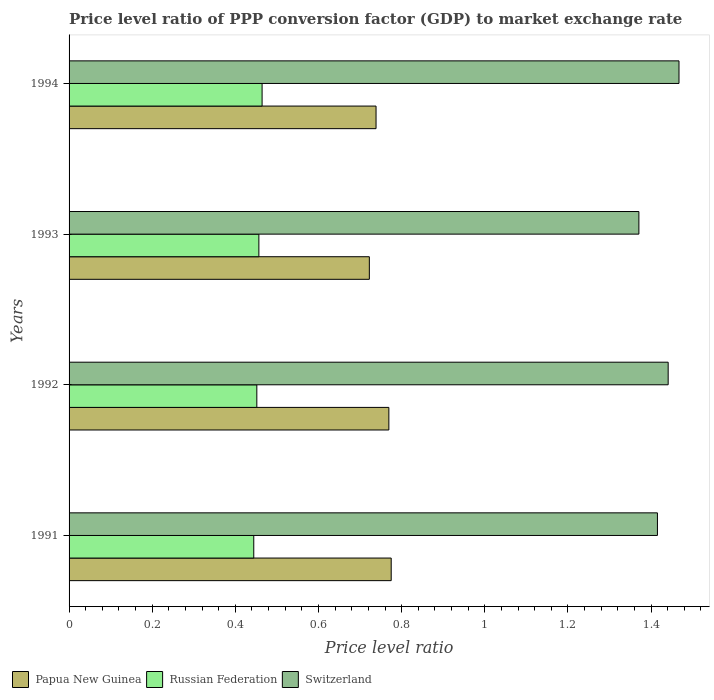How many different coloured bars are there?
Offer a terse response. 3. How many groups of bars are there?
Give a very brief answer. 4. How many bars are there on the 1st tick from the top?
Make the answer very short. 3. What is the label of the 1st group of bars from the top?
Make the answer very short. 1994. In how many cases, is the number of bars for a given year not equal to the number of legend labels?
Offer a very short reply. 0. What is the price level ratio in Russian Federation in 1993?
Ensure brevity in your answer.  0.46. Across all years, what is the maximum price level ratio in Papua New Guinea?
Give a very brief answer. 0.77. Across all years, what is the minimum price level ratio in Papua New Guinea?
Your response must be concise. 0.72. In which year was the price level ratio in Switzerland maximum?
Your response must be concise. 1994. What is the total price level ratio in Switzerland in the graph?
Give a very brief answer. 5.69. What is the difference between the price level ratio in Papua New Guinea in 1992 and that in 1993?
Make the answer very short. 0.05. What is the difference between the price level ratio in Papua New Guinea in 1992 and the price level ratio in Switzerland in 1994?
Your answer should be compact. -0.7. What is the average price level ratio in Papua New Guinea per year?
Make the answer very short. 0.75. In the year 1992, what is the difference between the price level ratio in Switzerland and price level ratio in Papua New Guinea?
Give a very brief answer. 0.67. In how many years, is the price level ratio in Papua New Guinea greater than 0.7200000000000001 ?
Provide a succinct answer. 4. What is the ratio of the price level ratio in Papua New Guinea in 1992 to that in 1993?
Provide a succinct answer. 1.06. Is the price level ratio in Papua New Guinea in 1991 less than that in 1993?
Provide a short and direct response. No. What is the difference between the highest and the second highest price level ratio in Papua New Guinea?
Provide a succinct answer. 0.01. What is the difference between the highest and the lowest price level ratio in Switzerland?
Provide a short and direct response. 0.1. In how many years, is the price level ratio in Russian Federation greater than the average price level ratio in Russian Federation taken over all years?
Offer a terse response. 2. Is the sum of the price level ratio in Papua New Guinea in 1992 and 1993 greater than the maximum price level ratio in Russian Federation across all years?
Make the answer very short. Yes. What does the 3rd bar from the top in 1993 represents?
Give a very brief answer. Papua New Guinea. What does the 2nd bar from the bottom in 1992 represents?
Keep it short and to the point. Russian Federation. How many bars are there?
Your answer should be very brief. 12. What is the difference between two consecutive major ticks on the X-axis?
Offer a terse response. 0.2. Does the graph contain any zero values?
Offer a very short reply. No. Where does the legend appear in the graph?
Offer a very short reply. Bottom left. What is the title of the graph?
Your answer should be very brief. Price level ratio of PPP conversion factor (GDP) to market exchange rate. What is the label or title of the X-axis?
Provide a short and direct response. Price level ratio. What is the label or title of the Y-axis?
Keep it short and to the point. Years. What is the Price level ratio in Papua New Guinea in 1991?
Provide a succinct answer. 0.77. What is the Price level ratio in Russian Federation in 1991?
Your answer should be very brief. 0.44. What is the Price level ratio of Switzerland in 1991?
Offer a very short reply. 1.42. What is the Price level ratio in Papua New Guinea in 1992?
Provide a succinct answer. 0.77. What is the Price level ratio of Russian Federation in 1992?
Provide a short and direct response. 0.45. What is the Price level ratio of Switzerland in 1992?
Offer a terse response. 1.44. What is the Price level ratio of Papua New Guinea in 1993?
Offer a terse response. 0.72. What is the Price level ratio in Russian Federation in 1993?
Make the answer very short. 0.46. What is the Price level ratio in Switzerland in 1993?
Your answer should be very brief. 1.37. What is the Price level ratio of Papua New Guinea in 1994?
Your response must be concise. 0.74. What is the Price level ratio in Russian Federation in 1994?
Provide a succinct answer. 0.46. What is the Price level ratio in Switzerland in 1994?
Make the answer very short. 1.47. Across all years, what is the maximum Price level ratio in Papua New Guinea?
Your response must be concise. 0.77. Across all years, what is the maximum Price level ratio of Russian Federation?
Give a very brief answer. 0.46. Across all years, what is the maximum Price level ratio in Switzerland?
Offer a very short reply. 1.47. Across all years, what is the minimum Price level ratio in Papua New Guinea?
Ensure brevity in your answer.  0.72. Across all years, what is the minimum Price level ratio in Russian Federation?
Offer a very short reply. 0.44. Across all years, what is the minimum Price level ratio in Switzerland?
Make the answer very short. 1.37. What is the total Price level ratio in Papua New Guinea in the graph?
Ensure brevity in your answer.  3. What is the total Price level ratio of Russian Federation in the graph?
Provide a succinct answer. 1.82. What is the total Price level ratio of Switzerland in the graph?
Provide a short and direct response. 5.69. What is the difference between the Price level ratio of Papua New Guinea in 1991 and that in 1992?
Ensure brevity in your answer.  0.01. What is the difference between the Price level ratio in Russian Federation in 1991 and that in 1992?
Give a very brief answer. -0.01. What is the difference between the Price level ratio in Switzerland in 1991 and that in 1992?
Make the answer very short. -0.03. What is the difference between the Price level ratio in Papua New Guinea in 1991 and that in 1993?
Your response must be concise. 0.05. What is the difference between the Price level ratio of Russian Federation in 1991 and that in 1993?
Provide a short and direct response. -0.01. What is the difference between the Price level ratio of Switzerland in 1991 and that in 1993?
Ensure brevity in your answer.  0.04. What is the difference between the Price level ratio of Papua New Guinea in 1991 and that in 1994?
Make the answer very short. 0.04. What is the difference between the Price level ratio in Russian Federation in 1991 and that in 1994?
Offer a very short reply. -0.02. What is the difference between the Price level ratio of Switzerland in 1991 and that in 1994?
Your answer should be very brief. -0.05. What is the difference between the Price level ratio in Papua New Guinea in 1992 and that in 1993?
Ensure brevity in your answer.  0.05. What is the difference between the Price level ratio of Russian Federation in 1992 and that in 1993?
Your response must be concise. -0. What is the difference between the Price level ratio in Switzerland in 1992 and that in 1993?
Give a very brief answer. 0.07. What is the difference between the Price level ratio of Papua New Guinea in 1992 and that in 1994?
Offer a very short reply. 0.03. What is the difference between the Price level ratio of Russian Federation in 1992 and that in 1994?
Provide a short and direct response. -0.01. What is the difference between the Price level ratio of Switzerland in 1992 and that in 1994?
Your answer should be compact. -0.03. What is the difference between the Price level ratio in Papua New Guinea in 1993 and that in 1994?
Give a very brief answer. -0.02. What is the difference between the Price level ratio in Russian Federation in 1993 and that in 1994?
Keep it short and to the point. -0.01. What is the difference between the Price level ratio in Switzerland in 1993 and that in 1994?
Your answer should be very brief. -0.1. What is the difference between the Price level ratio of Papua New Guinea in 1991 and the Price level ratio of Russian Federation in 1992?
Ensure brevity in your answer.  0.32. What is the difference between the Price level ratio of Papua New Guinea in 1991 and the Price level ratio of Switzerland in 1992?
Your response must be concise. -0.67. What is the difference between the Price level ratio of Russian Federation in 1991 and the Price level ratio of Switzerland in 1992?
Give a very brief answer. -1. What is the difference between the Price level ratio in Papua New Guinea in 1991 and the Price level ratio in Russian Federation in 1993?
Ensure brevity in your answer.  0.32. What is the difference between the Price level ratio in Papua New Guinea in 1991 and the Price level ratio in Switzerland in 1993?
Make the answer very short. -0.6. What is the difference between the Price level ratio of Russian Federation in 1991 and the Price level ratio of Switzerland in 1993?
Provide a short and direct response. -0.93. What is the difference between the Price level ratio of Papua New Guinea in 1991 and the Price level ratio of Russian Federation in 1994?
Give a very brief answer. 0.31. What is the difference between the Price level ratio of Papua New Guinea in 1991 and the Price level ratio of Switzerland in 1994?
Keep it short and to the point. -0.69. What is the difference between the Price level ratio in Russian Federation in 1991 and the Price level ratio in Switzerland in 1994?
Give a very brief answer. -1.02. What is the difference between the Price level ratio of Papua New Guinea in 1992 and the Price level ratio of Russian Federation in 1993?
Your answer should be very brief. 0.31. What is the difference between the Price level ratio of Papua New Guinea in 1992 and the Price level ratio of Switzerland in 1993?
Provide a short and direct response. -0.6. What is the difference between the Price level ratio in Russian Federation in 1992 and the Price level ratio in Switzerland in 1993?
Provide a succinct answer. -0.92. What is the difference between the Price level ratio in Papua New Guinea in 1992 and the Price level ratio in Russian Federation in 1994?
Offer a terse response. 0.3. What is the difference between the Price level ratio of Papua New Guinea in 1992 and the Price level ratio of Switzerland in 1994?
Offer a terse response. -0.7. What is the difference between the Price level ratio in Russian Federation in 1992 and the Price level ratio in Switzerland in 1994?
Ensure brevity in your answer.  -1.02. What is the difference between the Price level ratio in Papua New Guinea in 1993 and the Price level ratio in Russian Federation in 1994?
Make the answer very short. 0.26. What is the difference between the Price level ratio in Papua New Guinea in 1993 and the Price level ratio in Switzerland in 1994?
Ensure brevity in your answer.  -0.74. What is the difference between the Price level ratio of Russian Federation in 1993 and the Price level ratio of Switzerland in 1994?
Your answer should be very brief. -1.01. What is the average Price level ratio in Papua New Guinea per year?
Your answer should be very brief. 0.75. What is the average Price level ratio in Russian Federation per year?
Your answer should be very brief. 0.45. What is the average Price level ratio in Switzerland per year?
Offer a terse response. 1.42. In the year 1991, what is the difference between the Price level ratio of Papua New Guinea and Price level ratio of Russian Federation?
Make the answer very short. 0.33. In the year 1991, what is the difference between the Price level ratio of Papua New Guinea and Price level ratio of Switzerland?
Keep it short and to the point. -0.64. In the year 1991, what is the difference between the Price level ratio in Russian Federation and Price level ratio in Switzerland?
Provide a succinct answer. -0.97. In the year 1992, what is the difference between the Price level ratio in Papua New Guinea and Price level ratio in Russian Federation?
Provide a short and direct response. 0.32. In the year 1992, what is the difference between the Price level ratio of Papua New Guinea and Price level ratio of Switzerland?
Offer a very short reply. -0.67. In the year 1992, what is the difference between the Price level ratio of Russian Federation and Price level ratio of Switzerland?
Give a very brief answer. -0.99. In the year 1993, what is the difference between the Price level ratio in Papua New Guinea and Price level ratio in Russian Federation?
Your answer should be very brief. 0.27. In the year 1993, what is the difference between the Price level ratio of Papua New Guinea and Price level ratio of Switzerland?
Provide a succinct answer. -0.65. In the year 1993, what is the difference between the Price level ratio in Russian Federation and Price level ratio in Switzerland?
Provide a succinct answer. -0.91. In the year 1994, what is the difference between the Price level ratio of Papua New Guinea and Price level ratio of Russian Federation?
Give a very brief answer. 0.27. In the year 1994, what is the difference between the Price level ratio in Papua New Guinea and Price level ratio in Switzerland?
Your response must be concise. -0.73. In the year 1994, what is the difference between the Price level ratio of Russian Federation and Price level ratio of Switzerland?
Your answer should be compact. -1. What is the ratio of the Price level ratio in Papua New Guinea in 1991 to that in 1992?
Ensure brevity in your answer.  1.01. What is the ratio of the Price level ratio in Russian Federation in 1991 to that in 1992?
Your answer should be very brief. 0.98. What is the ratio of the Price level ratio of Switzerland in 1991 to that in 1992?
Ensure brevity in your answer.  0.98. What is the ratio of the Price level ratio of Papua New Guinea in 1991 to that in 1993?
Your answer should be compact. 1.07. What is the ratio of the Price level ratio of Russian Federation in 1991 to that in 1993?
Offer a terse response. 0.97. What is the ratio of the Price level ratio in Switzerland in 1991 to that in 1993?
Offer a very short reply. 1.03. What is the ratio of the Price level ratio of Papua New Guinea in 1991 to that in 1994?
Make the answer very short. 1.05. What is the ratio of the Price level ratio of Russian Federation in 1991 to that in 1994?
Ensure brevity in your answer.  0.96. What is the ratio of the Price level ratio in Switzerland in 1991 to that in 1994?
Keep it short and to the point. 0.96. What is the ratio of the Price level ratio of Papua New Guinea in 1992 to that in 1993?
Your response must be concise. 1.06. What is the ratio of the Price level ratio of Russian Federation in 1992 to that in 1993?
Offer a very short reply. 0.99. What is the ratio of the Price level ratio in Switzerland in 1992 to that in 1993?
Provide a succinct answer. 1.05. What is the ratio of the Price level ratio in Papua New Guinea in 1992 to that in 1994?
Offer a terse response. 1.04. What is the ratio of the Price level ratio in Russian Federation in 1992 to that in 1994?
Your response must be concise. 0.97. What is the ratio of the Price level ratio in Switzerland in 1992 to that in 1994?
Your response must be concise. 0.98. What is the ratio of the Price level ratio in Papua New Guinea in 1993 to that in 1994?
Ensure brevity in your answer.  0.98. What is the ratio of the Price level ratio in Russian Federation in 1993 to that in 1994?
Your response must be concise. 0.98. What is the ratio of the Price level ratio of Switzerland in 1993 to that in 1994?
Your answer should be compact. 0.93. What is the difference between the highest and the second highest Price level ratio of Papua New Guinea?
Offer a terse response. 0.01. What is the difference between the highest and the second highest Price level ratio of Russian Federation?
Ensure brevity in your answer.  0.01. What is the difference between the highest and the second highest Price level ratio of Switzerland?
Provide a succinct answer. 0.03. What is the difference between the highest and the lowest Price level ratio of Papua New Guinea?
Keep it short and to the point. 0.05. What is the difference between the highest and the lowest Price level ratio in Switzerland?
Offer a terse response. 0.1. 